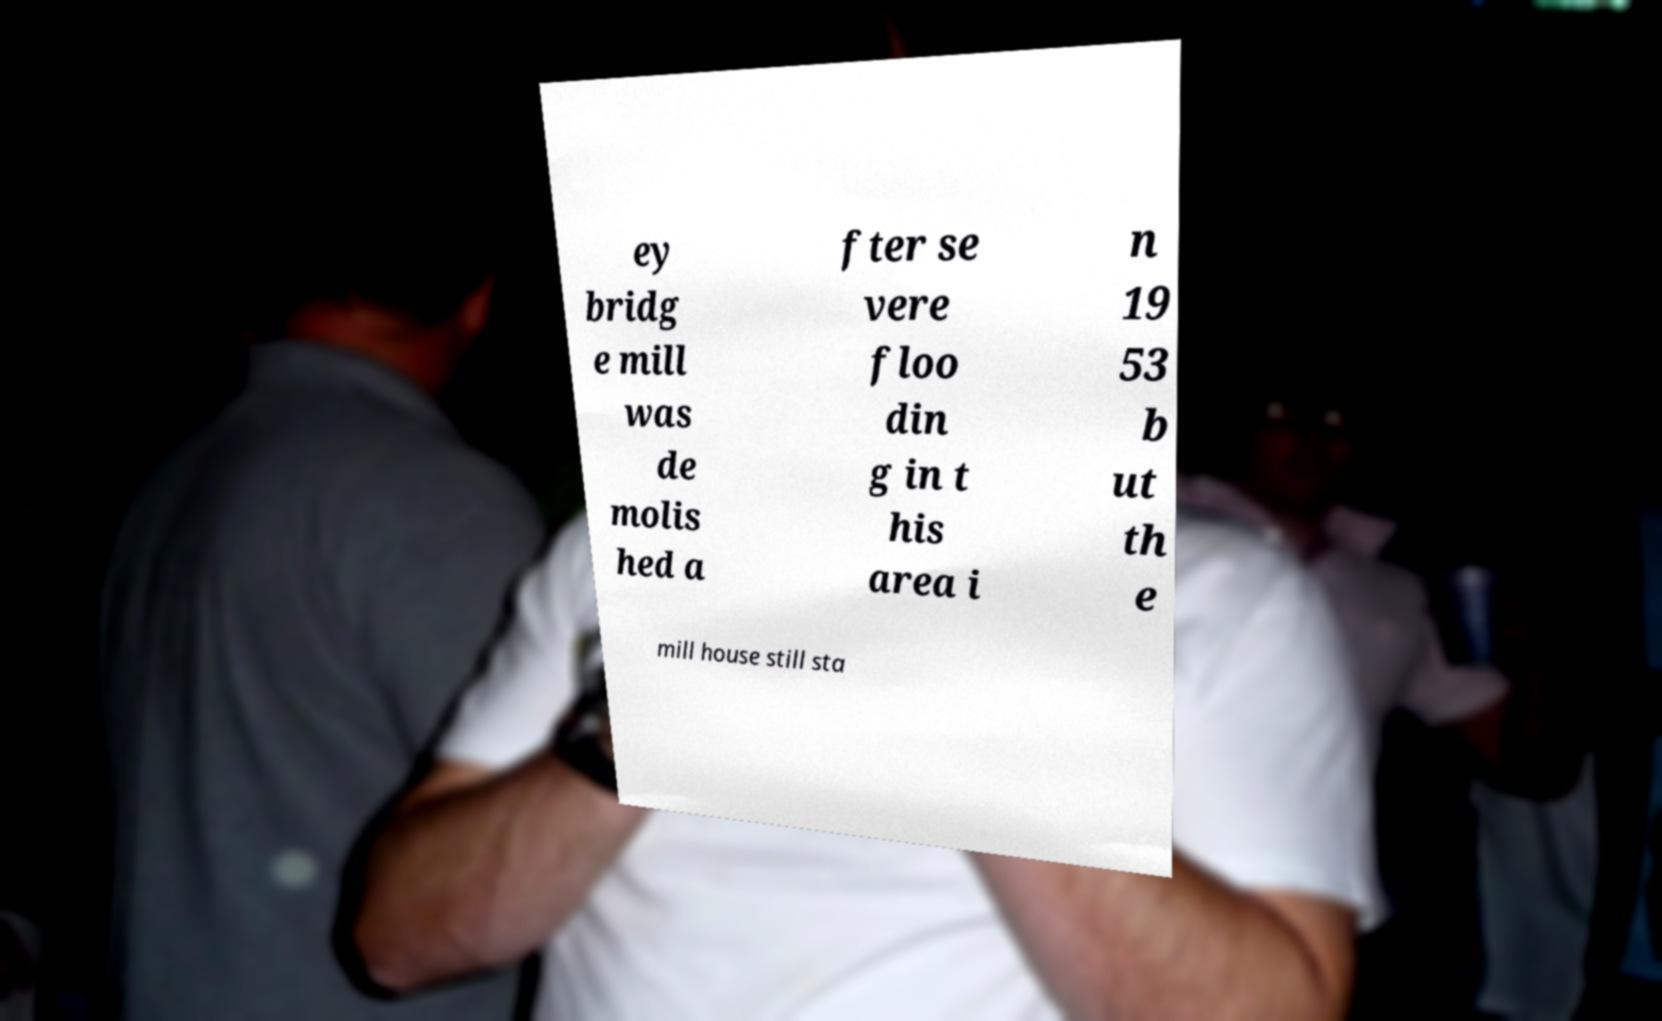I need the written content from this picture converted into text. Can you do that? ey bridg e mill was de molis hed a fter se vere floo din g in t his area i n 19 53 b ut th e mill house still sta 